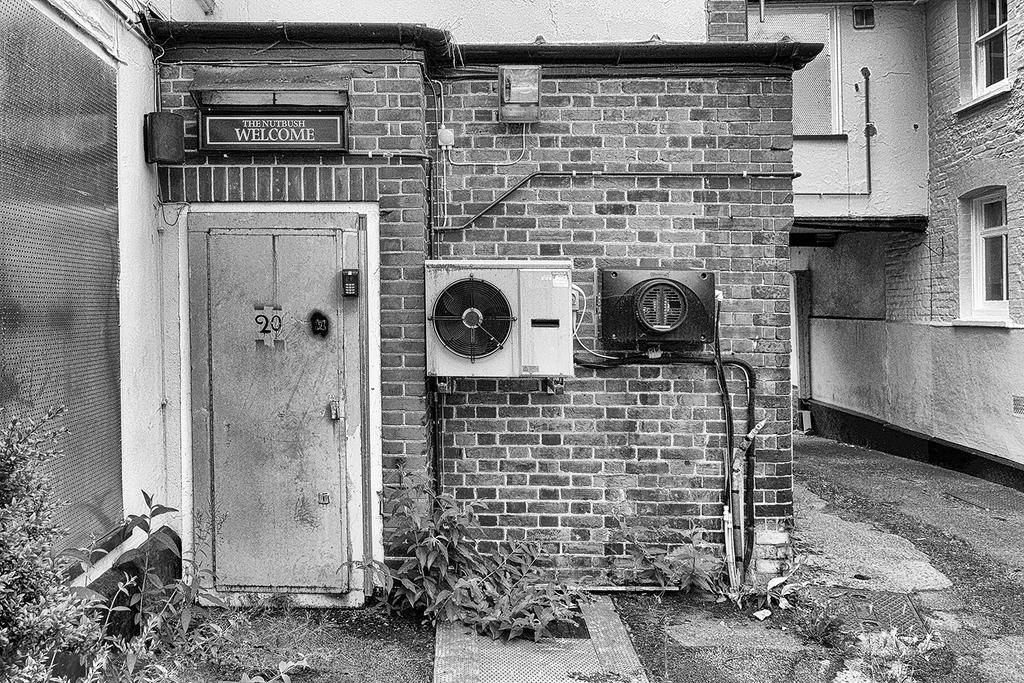What type of structures can be seen in the image? There are houses in the image. What type of construction material is visible in the image? There is a brick wall in the image. What type of equipment is present in the image? There are machines in the image. What type of entrance is visible in the image? There is a door in the image. What type of signage is present in the image? There is a name board in the image. What type of plumbing infrastructure is visible in the image? There are pipes in the image. What type of openings are present in the structures in the image? There are windows in the image. What type of pathway is visible at the bottom of the image? There is a walkway at the bottom of the image. What type of vegetation is present at the bottom of the image? There are plants at the bottom of the image. What type of beef is being cooked on the machines in the image? There is no beef or cooking activity present in the image; the machines are not related to food preparation. What type of jeans are being worn by the plants at the bottom of the image? There are no jeans present in the image; the plants are not associated with clothing. 